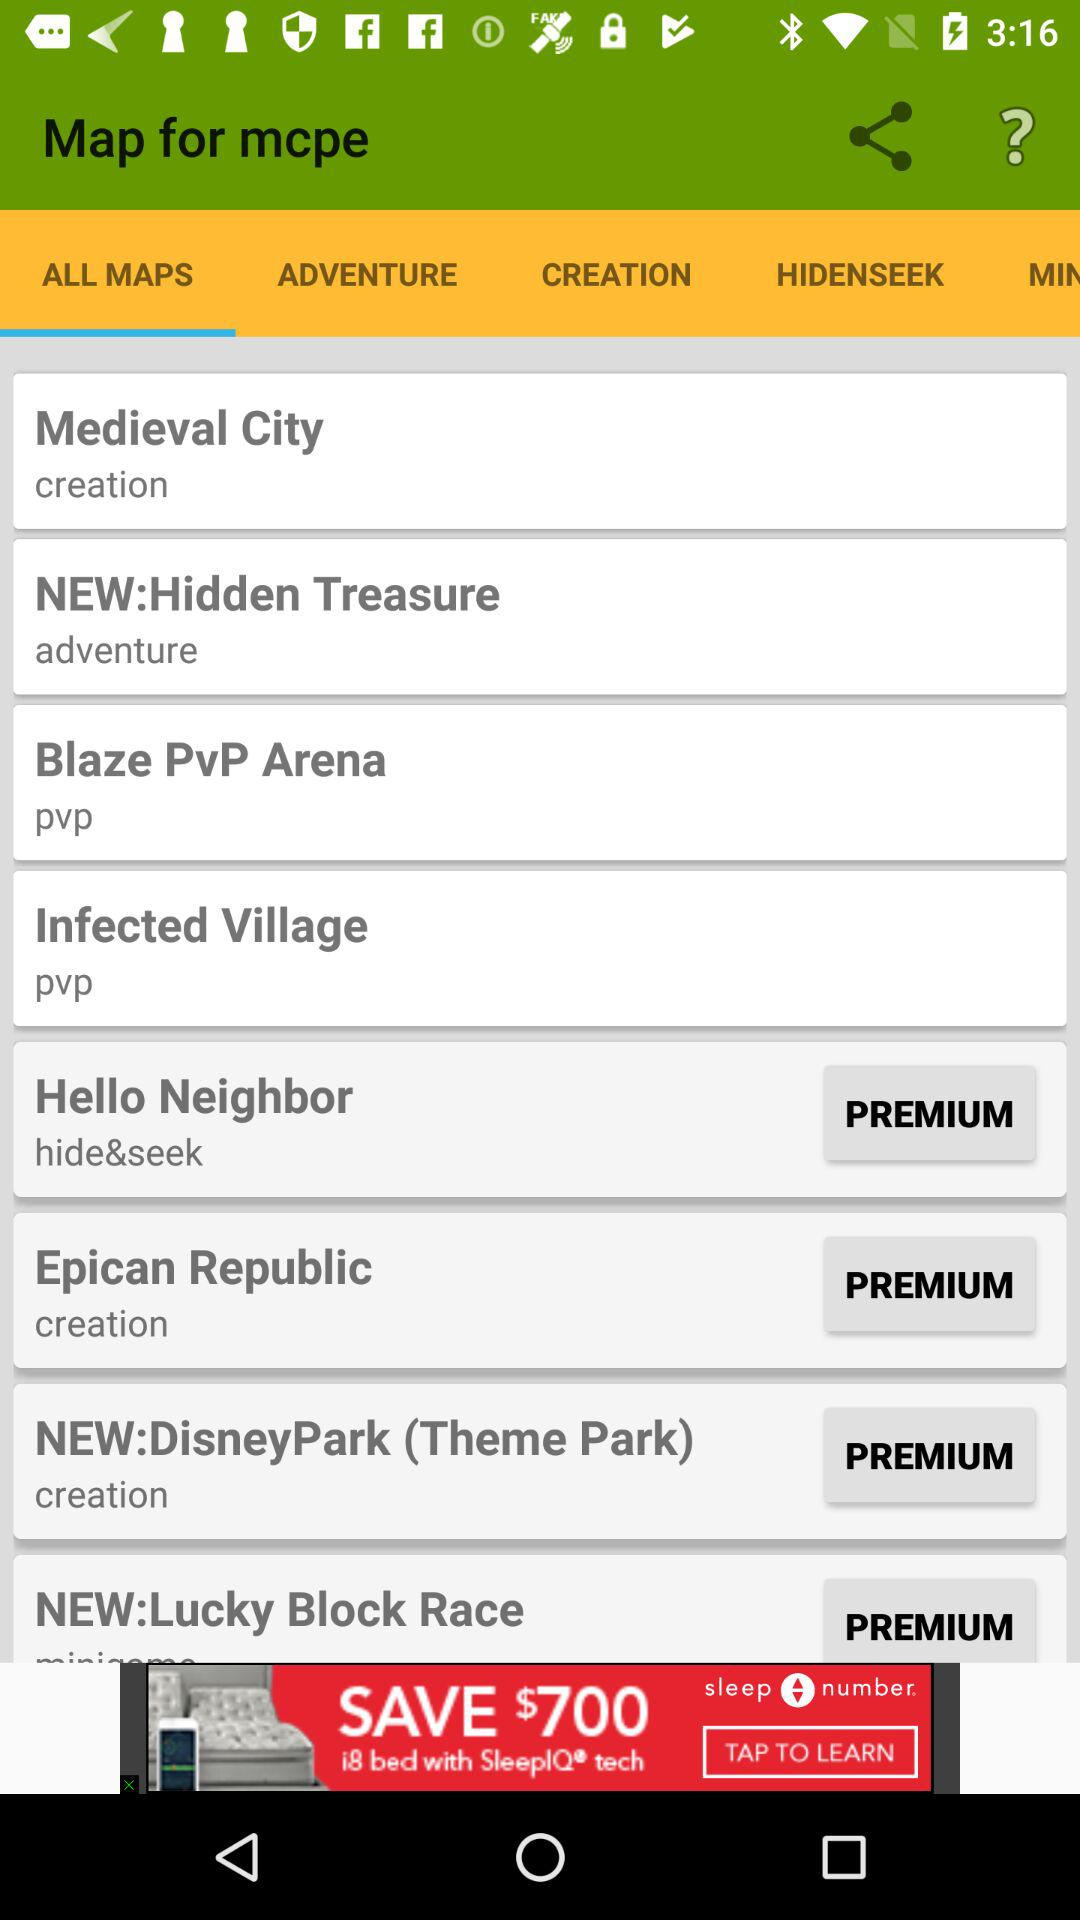How many of the maps are premium?
Answer the question using a single word or phrase. 4 